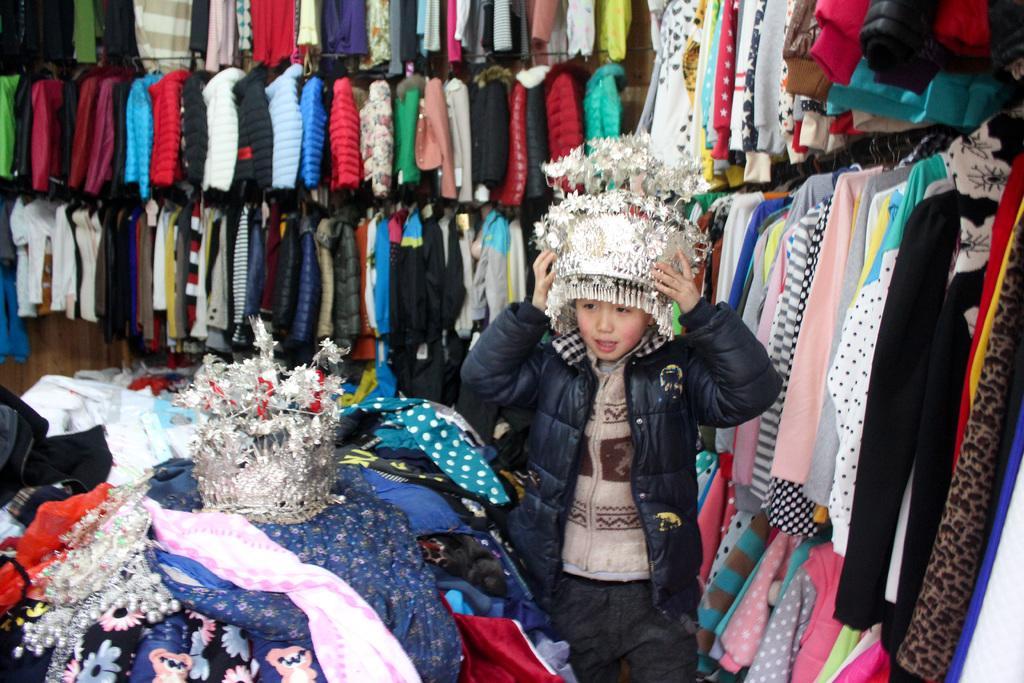Can you describe this image briefly? In this picture there is a kid wearing black color jacket and head wear on his head. There are several clothes here. In the background there are some jackets hanged to the hangers. 